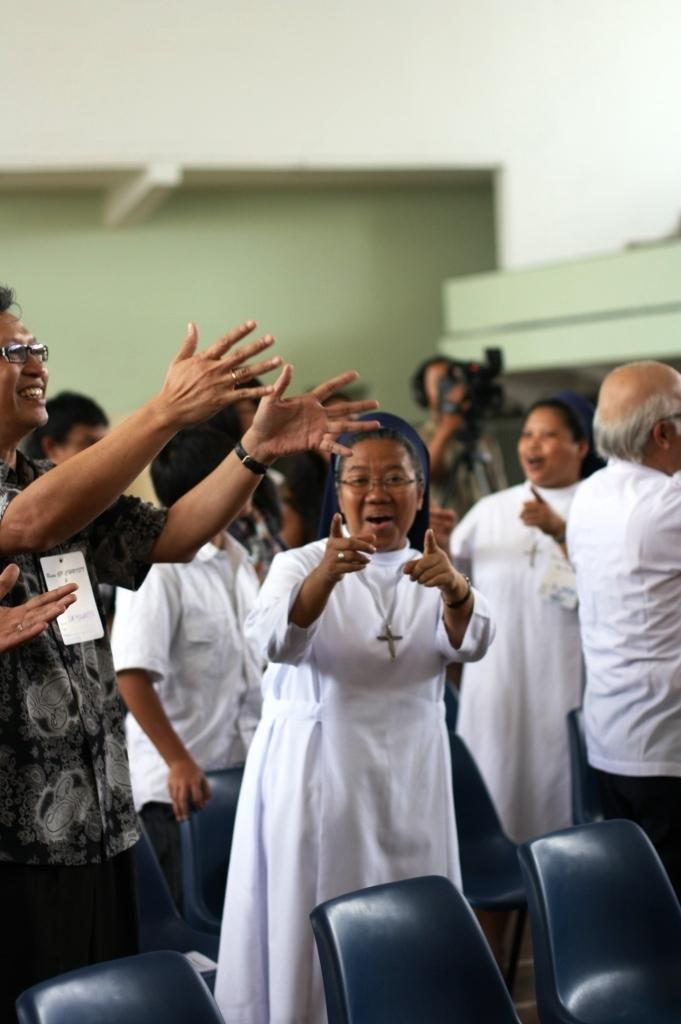What can be observed about the people in the image? There are people standing in the image, and some of them have smiles on their faces. What objects are present in the image that the people might use? There are chairs in the image that the people might use. What type of lumber is being pulled by the yak in the image? There is no yak or lumber present in the image; it only features people and chairs. 